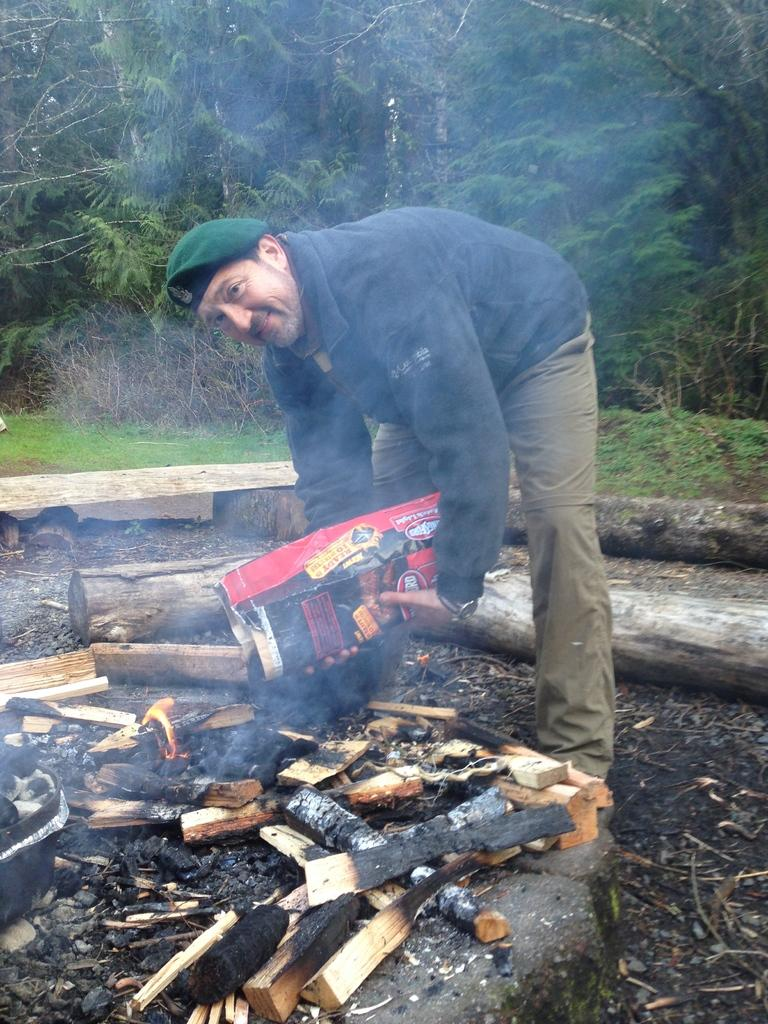Who is present in the image? There is a man in the image. What is the man holding in the image? The man is holding a paper bag. Can you describe the man's attire in the image? The man is wearing a cap and a jacket. What can be seen in the image related to fire? There is wood with fire in the image. What type of natural element is visible in the image? There is tree bark and trees visible in the image. What is the man's wealth status based on the image? There is no information about the man's wealth status in the image. How many hands does the man have in the image? The man has two hands in the image, but the number of hands cannot be determined from the image alone. 